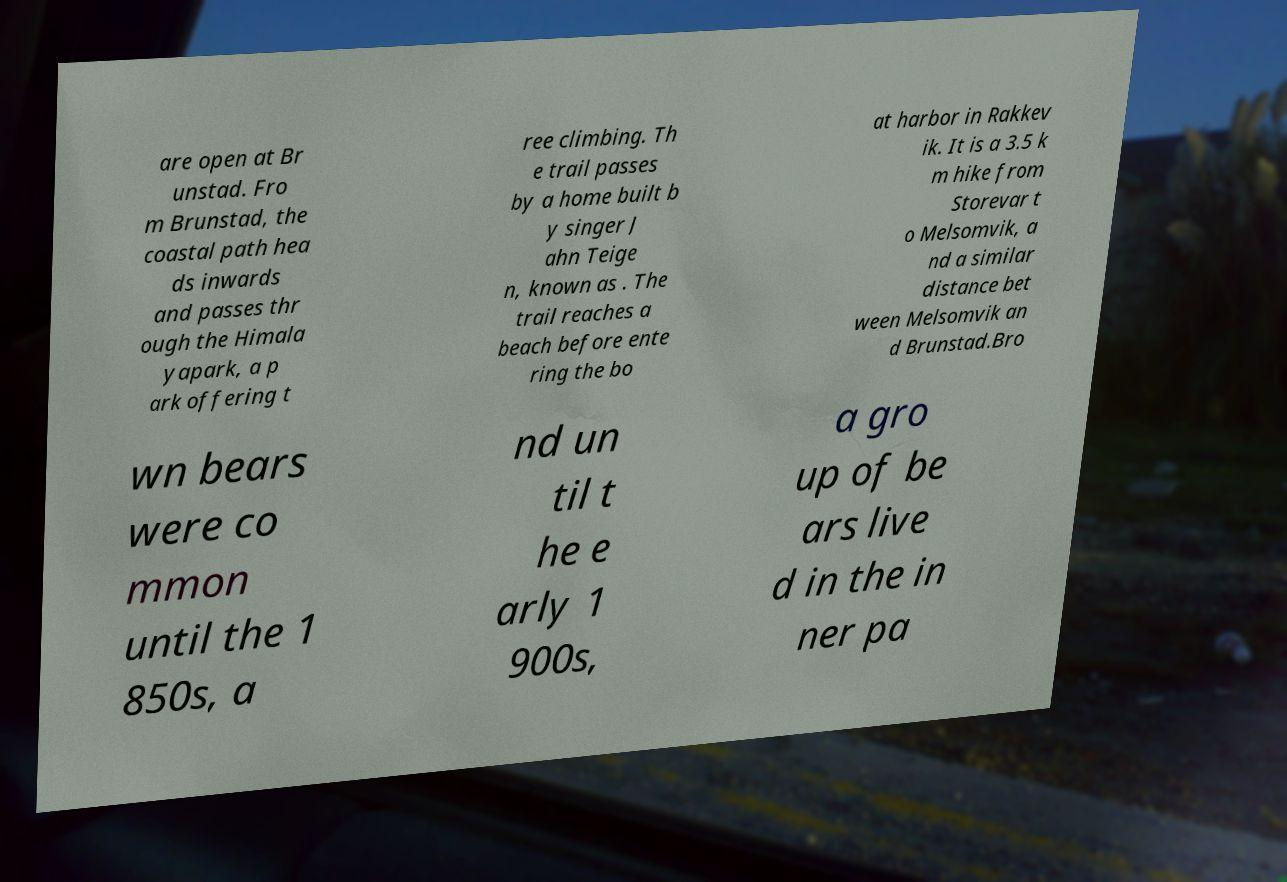For documentation purposes, I need the text within this image transcribed. Could you provide that? are open at Br unstad. Fro m Brunstad, the coastal path hea ds inwards and passes thr ough the Himala yapark, a p ark offering t ree climbing. Th e trail passes by a home built b y singer J ahn Teige n, known as . The trail reaches a beach before ente ring the bo at harbor in Rakkev ik. It is a 3.5 k m hike from Storevar t o Melsomvik, a nd a similar distance bet ween Melsomvik an d Brunstad.Bro wn bears were co mmon until the 1 850s, a nd un til t he e arly 1 900s, a gro up of be ars live d in the in ner pa 